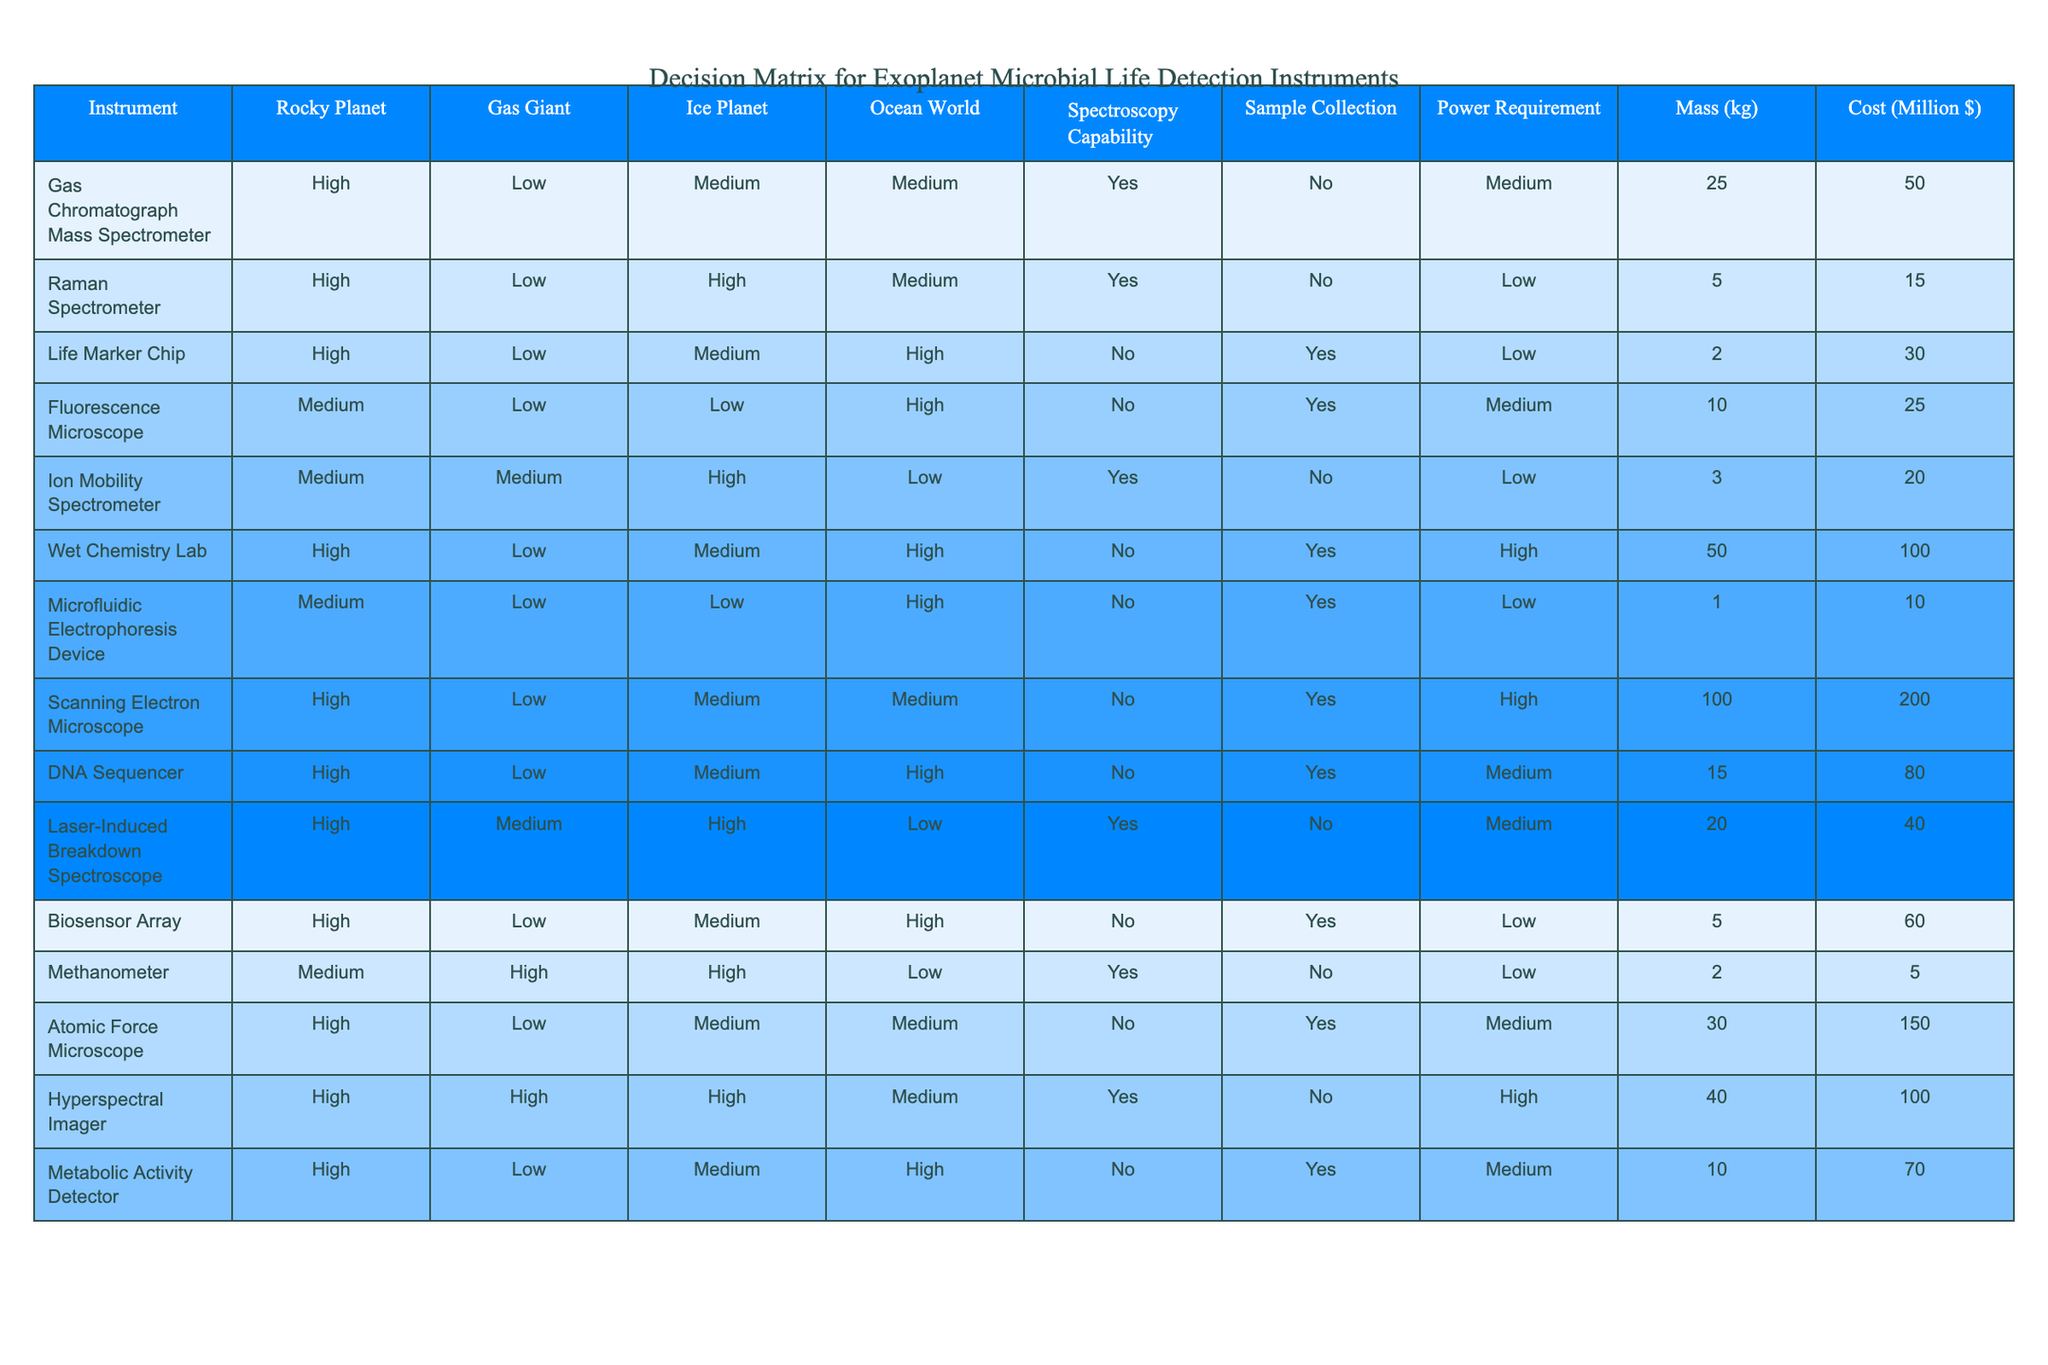What is the power requirement for the Gas Chromatograph Mass Spectrometer? The power requirement for the Gas Chromatograph Mass Spectrometer can be found in the corresponding row under the "Power Requirement" column. It shows "Medium".
Answer: Medium Which instrument has the highest mass? By examining the "Mass (kg)" column, the Scanning Electron Microscope has a mass of 100 kg, which is the highest in the table.
Answer: 100 kg Can the Life Marker Chip be used on a Gas Giant? The table indicates that the Life Marker Chip has a "Low" capability for detecting life on a Gas Giant, meaning it is not suitable for this type of exoplanet.
Answer: No What instruments can collect samples on Ocean Worlds? Looking at the "Sample Collection" column for Ocean Worlds, there are the Life Marker Chip, Fluorescence Microscope, Wet Chemistry Lab, Microfluidic Electrophoresis Device, DNA Sequencer, and Metabolic Activity Detector that can collect samples.
Answer: 6 What is the average cost of instruments with high spectroscopy capability? The relevant instruments with "Yes" under the Spectroscopy Capability column are the Gas Chromatograph Mass Spectrometer, Raman Spectrometer, Ion Mobility Spectrometer, Laser-Induced Breakdown Spectroscope, and Hyperspectral Imager. Their costs are 50, 15, 20, 40, and 100 million dollars respectively. To find the average: (50 + 15 + 20 + 40 + 100) = 225 million, then 225/5 = 45 million.
Answer: 45 million Which instrument has the lowest cost, and what is it? By reviewing the "Cost (Million $)" column, the Methanometer has the lowest cost of 5 million dollars, making it the least expensive instrument on the list.
Answer: 5 million Are there any instruments that can be used on both Rocky and Ocean Worlds? Checking the columns for Rocky Planet and Ocean World, the relevant instruments that appear in both categories are the Gas Chromatograph Mass Spectrometer, Life Marker Chip, and Wet Chemistry Lab, indicating that these can be utilized on both types of exoplanets.
Answer: 3 Which instrument requires the most power? The "Power Requirement" for each instrument indicates that the Wet Chemistry Lab has a "High" requirement, which is the most among the listed instruments.
Answer: High 